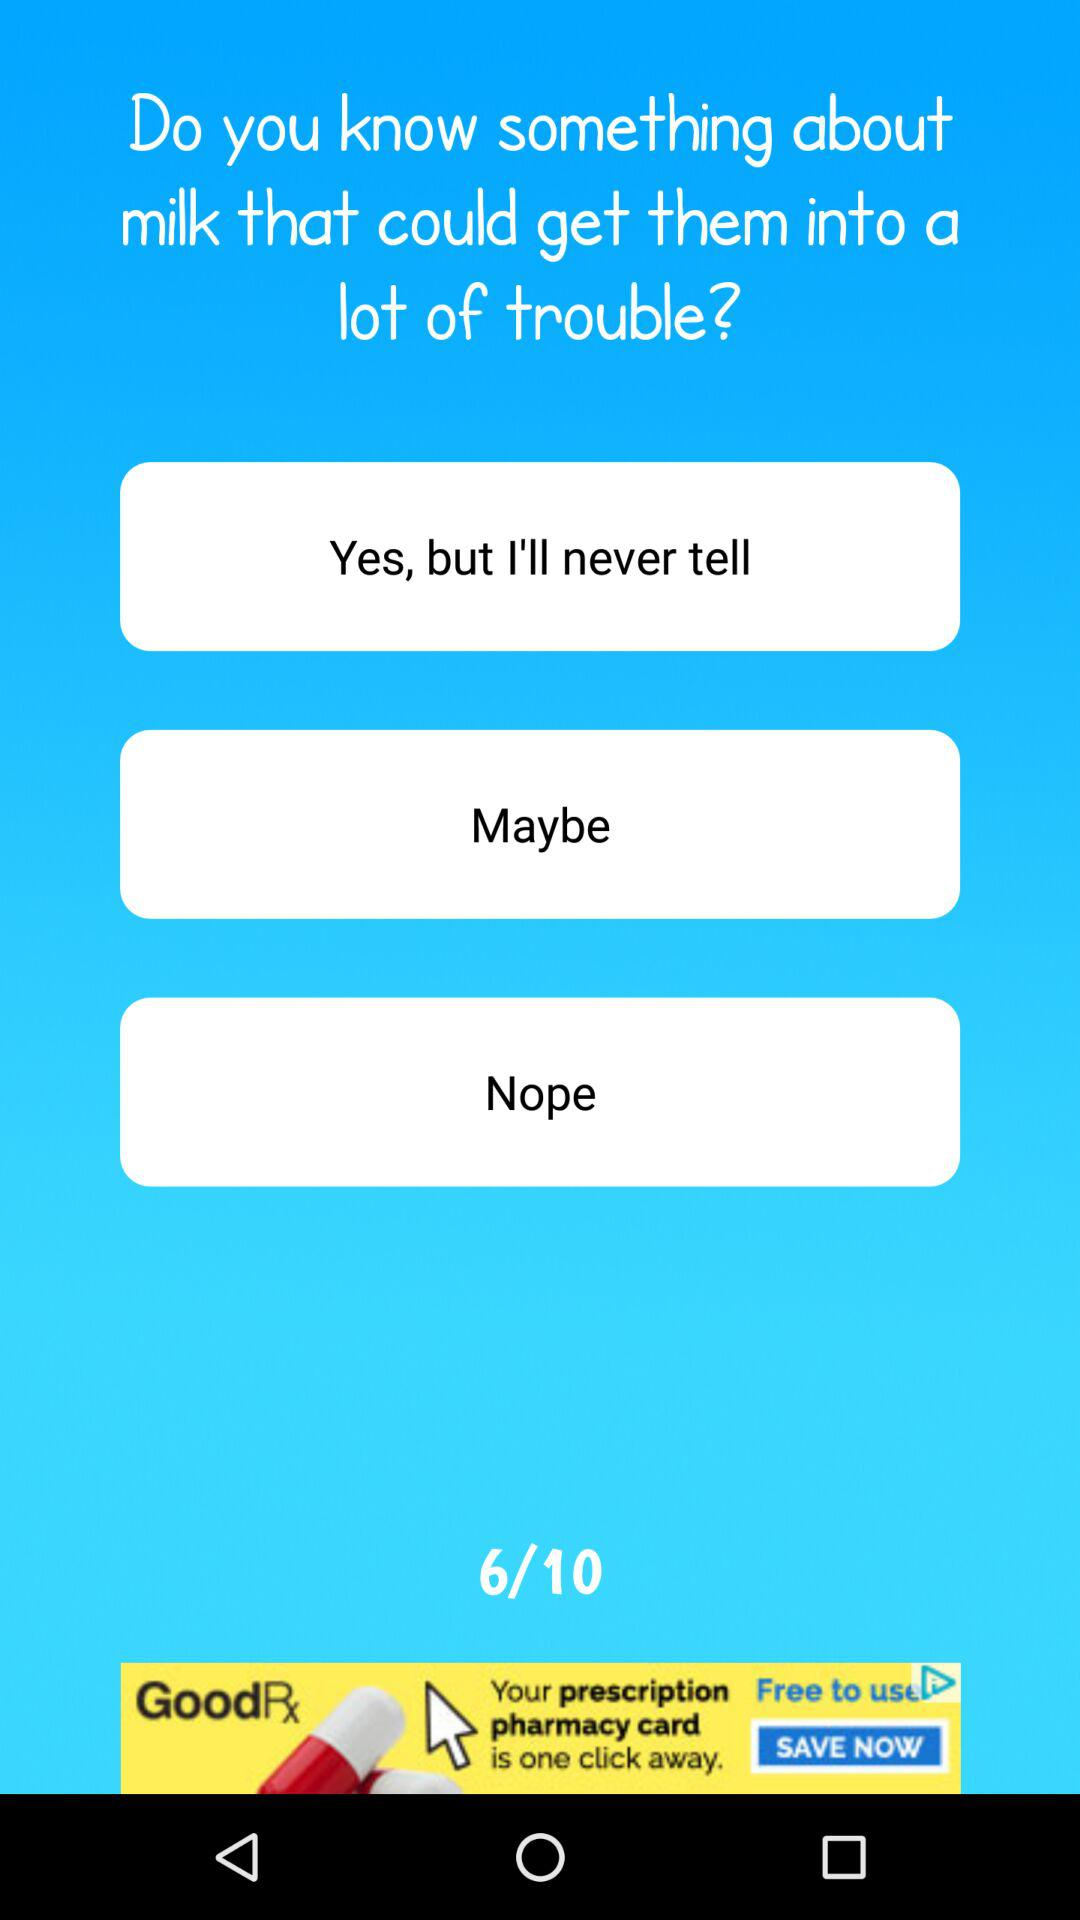How many questions are correct?
When the provided information is insufficient, respond with <no answer>. <no answer> 